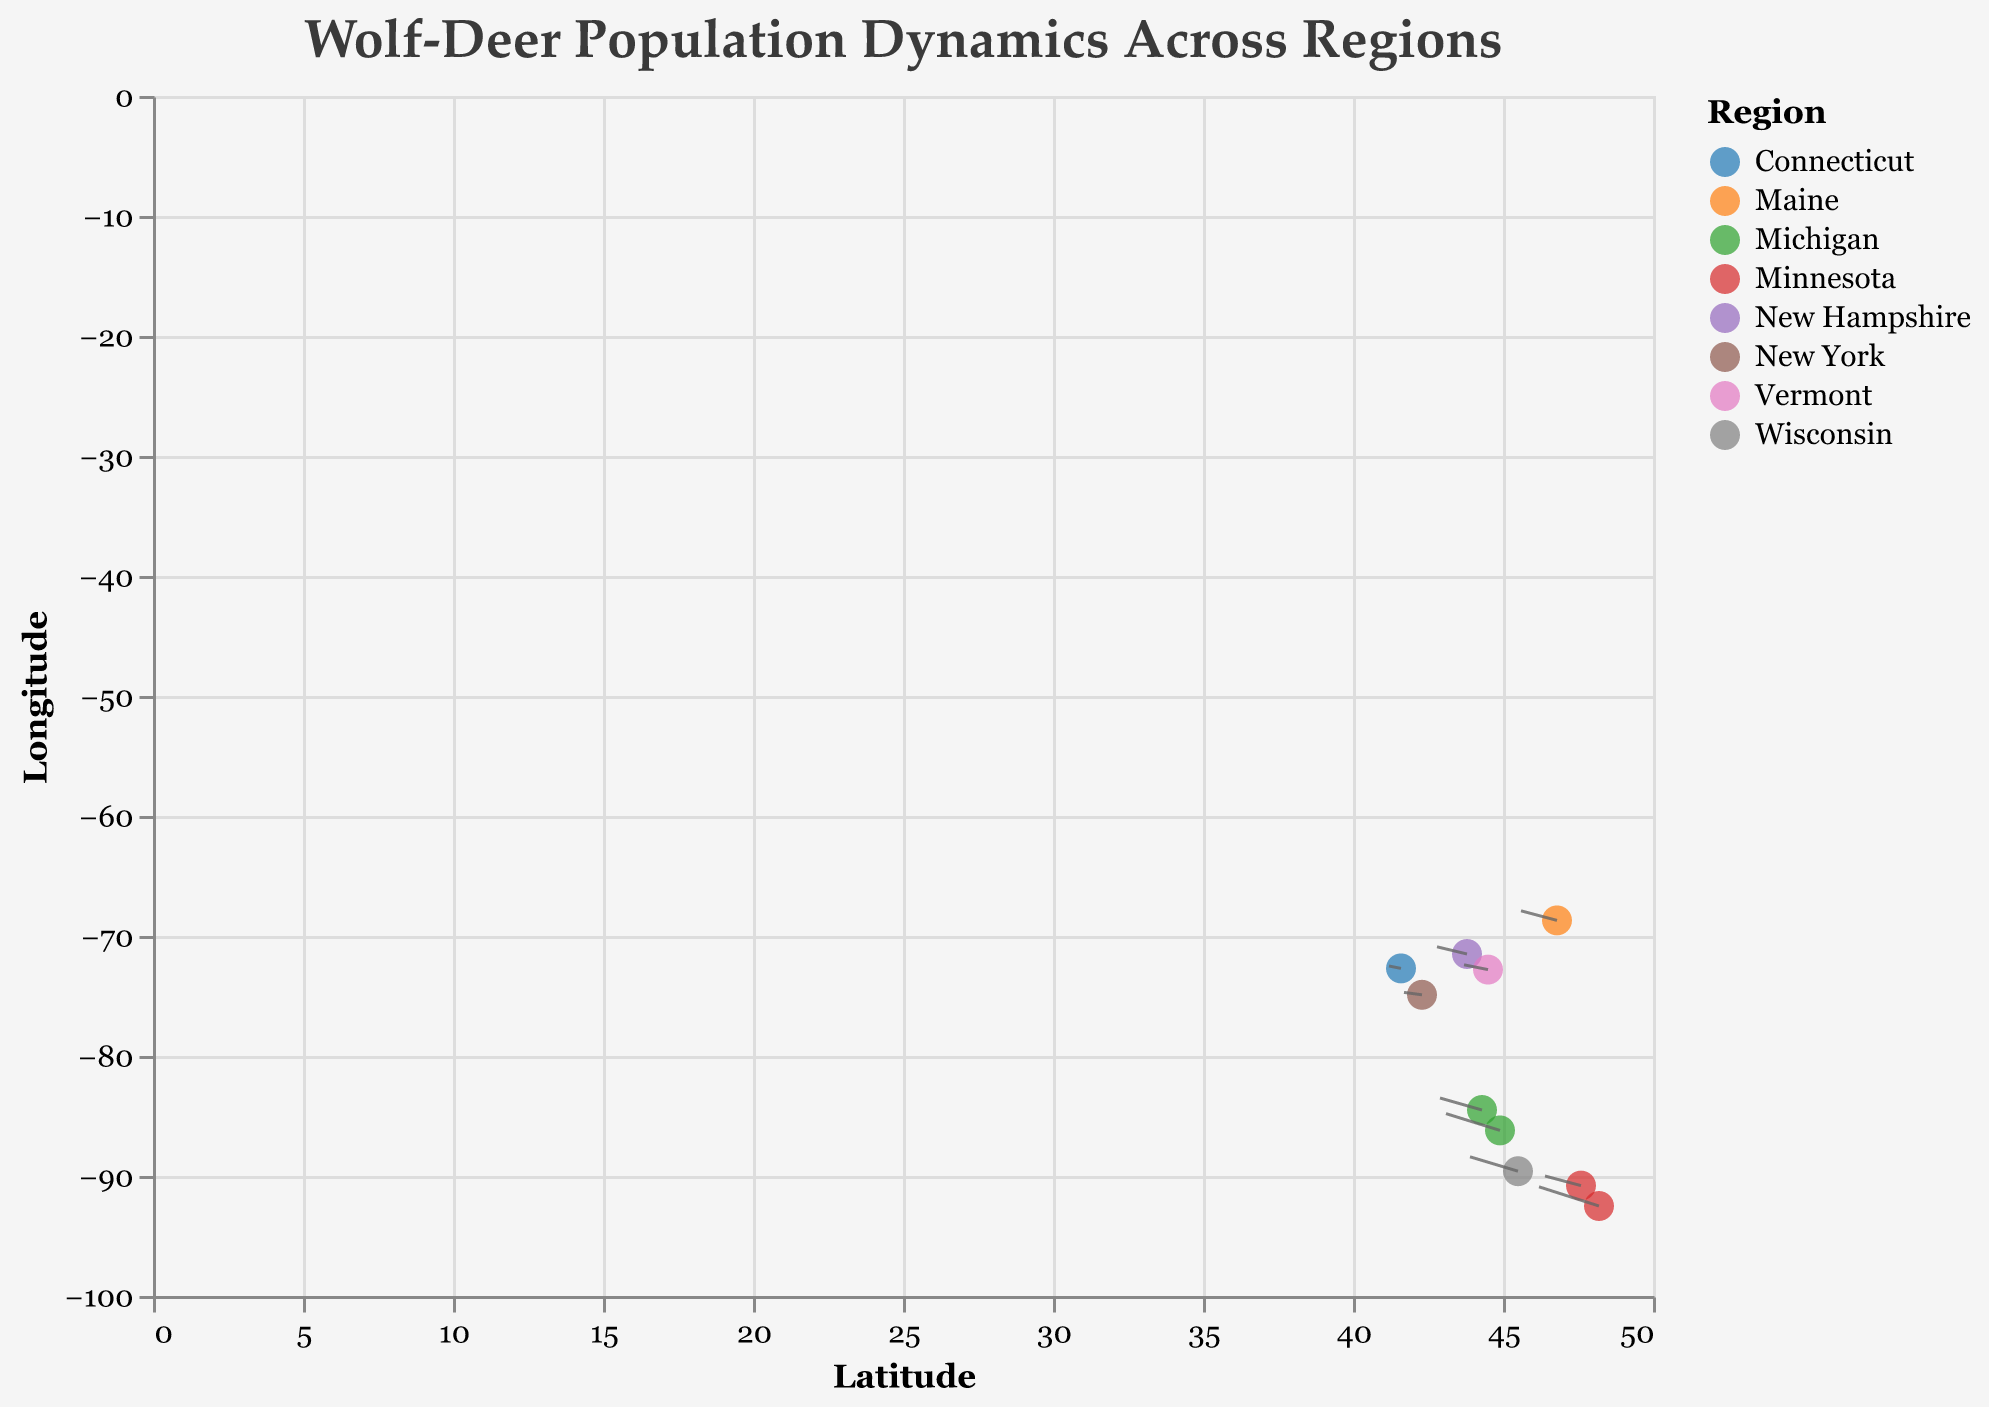What's the title of the figure? The title is displayed at the top of the figure. It reads, "Wolf-Deer Population Dynamics Across Regions".
Answer: Wolf-Deer Population Dynamics Across Regions Which region shows the highest wolf population change? Looking at the vector arrows in the figure, the region with the longest vector in the horizontal direction (u) indicates the highest change in wolf population. Minnesota (48.2, -92.5) has the vector with the largest u value of -1.0.
Answer: Minnesota What's the latitude and longitude of the data point representing New Hampshire? The tooltip shows that New Hampshire is located at the coordinates (43.8, -71.5).
Answer: 43.8, -71.5 Which region has the smallest deer population change? The data with the smallest vertical vector (v) indicates the smallest deer population change. Connecticut (41.6, -72.7) has the vector with the smallest v value of 0.1.
Answer: Connecticut How many data points are included in the figure? By counting each coordinate pair (latitude, longitude), there are 10 data points in the figure.
Answer: 10 Compare the deer population change between Wisconsin and Michigan regions. Which one has a higher change? By observing the length of the vertical vectors for these regions, the deer population change in Michigan (-0.9, 0.7) is higher (0.7) than in Wisconsin (-0.8, 0.6), which is 0.6.
Answer: Michigan What are the x and y axes titles in the figure? The x-axis title is "Latitude", and the y-axis title is "Longitude" as specified in the axis titles on the plot.
Answer: Latitude and Longitude Which region shows the least wolf population change? The vector with the smallest u value indicates the least wolf population change. Connecticut (41.6, -72.7) has the smallest u value of -0.2.
Answer: Connecticut Which regions are represented by vectors with the same length but different directions? The length of the vectors can be compared by looking at the combined (u, v) values. Minnesota (47.6, -90.8) and Maine (46.8, -68.7) have vectors each with magnitudes of (0.6, 0.4).
Answer: Minnesota and Maine 